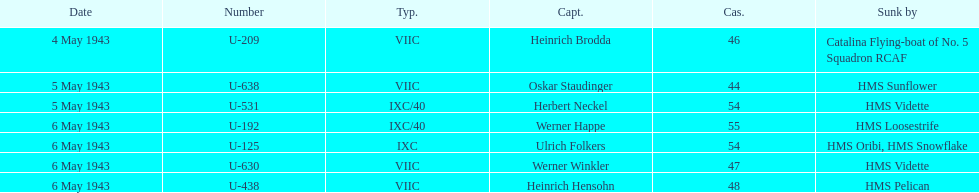Aside from oskar staudinger what was the name of the other captain of the u-boat loast on may 5? Herbert Neckel. 